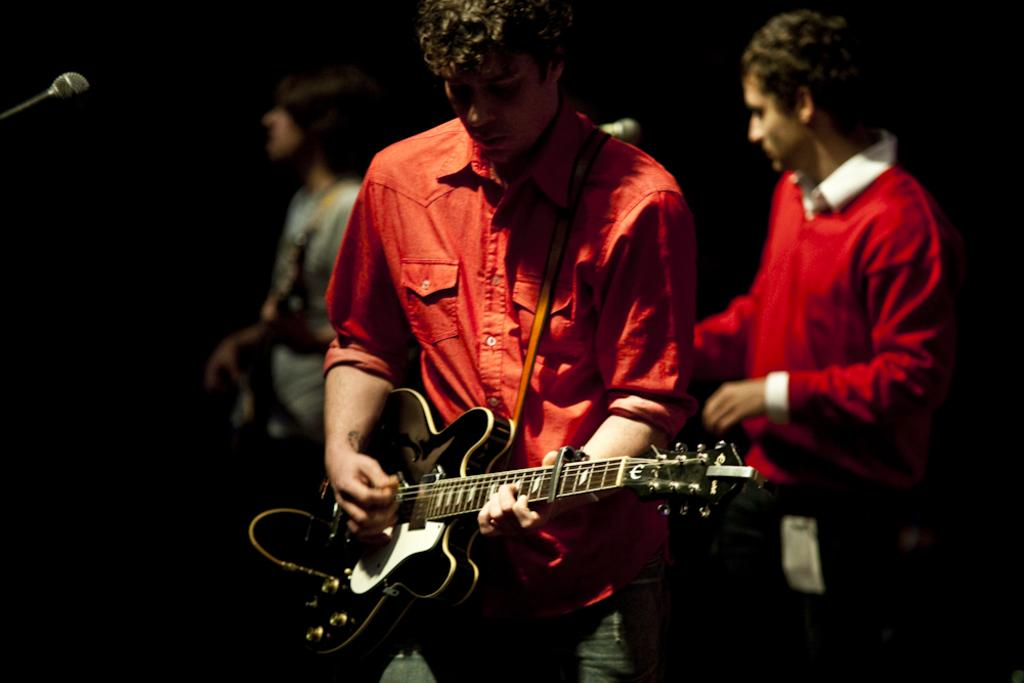How many people are in the image? There are three people in the image. What are the people doing in the image? The people are standing and playing guitar. What can be seen in front of the people? They are standing in front of a microphone. What is the lighting condition in the image? The background of the image is dark, and it was taken during night time. What event is the image depicting? The image was taken at a concert. Can you tell me how many grapes are on the guitar in the image? There are no grapes present on the guitar in the image. What type of flame can be seen in the image? There is no flame present in the image. 